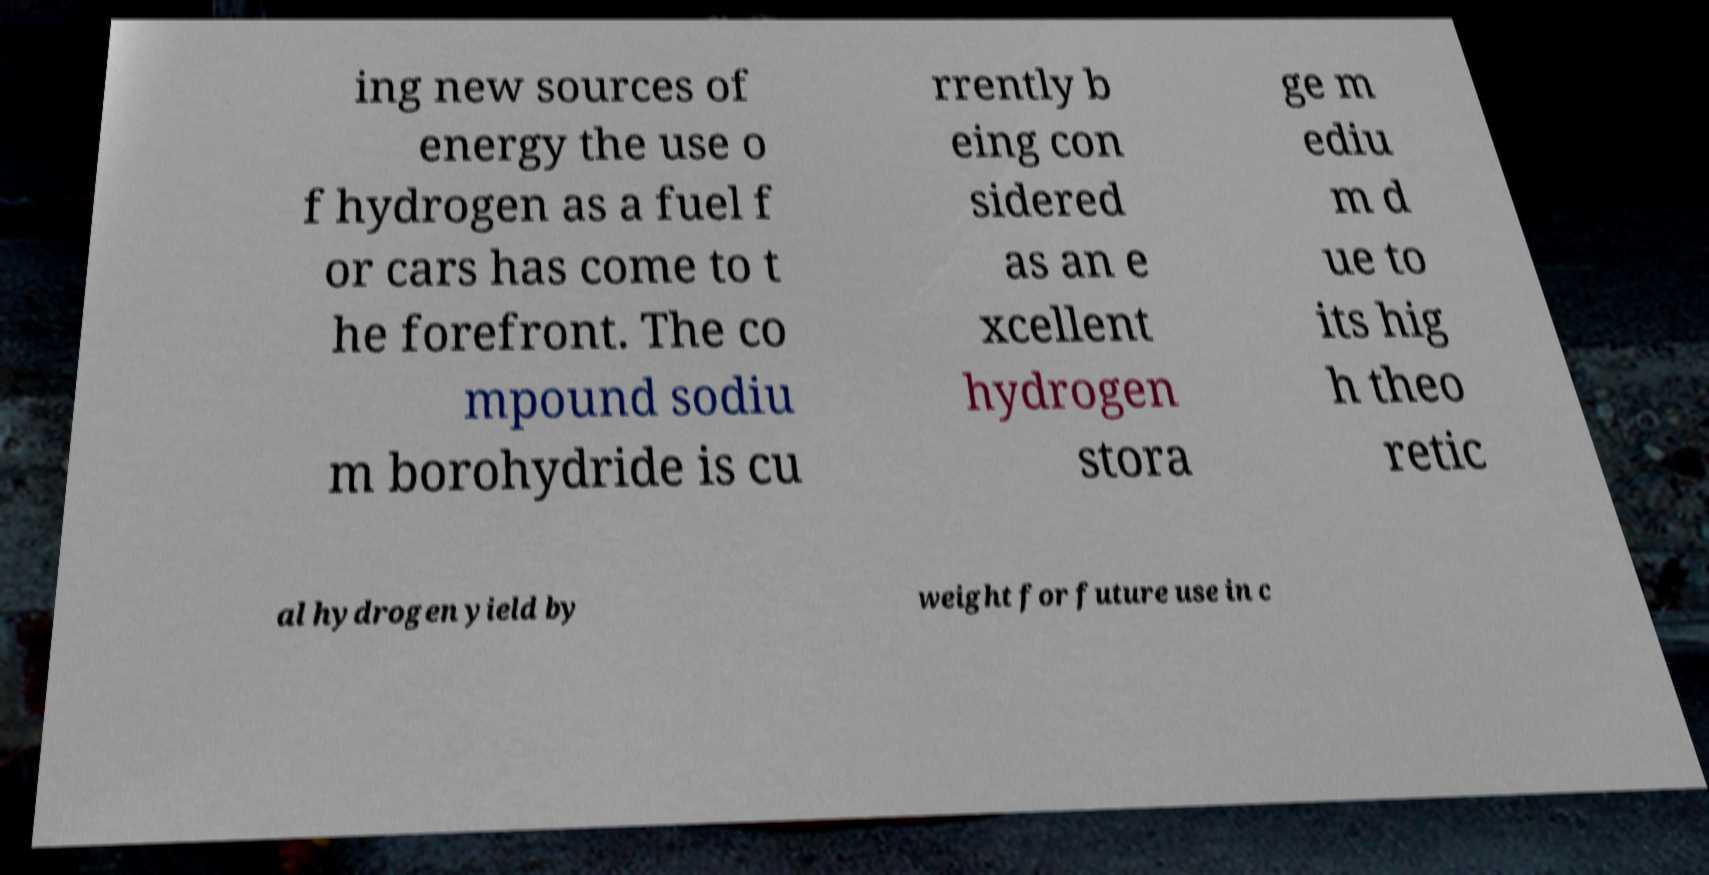Could you assist in decoding the text presented in this image and type it out clearly? ing new sources of energy the use o f hydrogen as a fuel f or cars has come to t he forefront. The co mpound sodiu m borohydride is cu rrently b eing con sidered as an e xcellent hydrogen stora ge m ediu m d ue to its hig h theo retic al hydrogen yield by weight for future use in c 